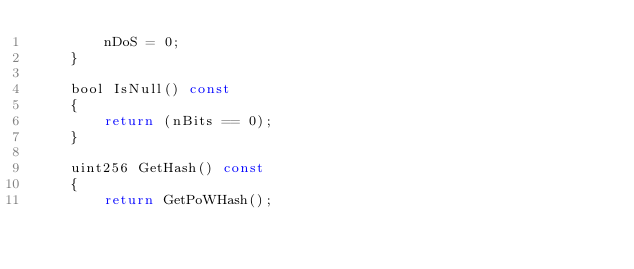<code> <loc_0><loc_0><loc_500><loc_500><_C_>        nDoS = 0;
    }

    bool IsNull() const
    {
        return (nBits == 0);
    }

    uint256 GetHash() const
    {
        return GetPoWHash();</code> 